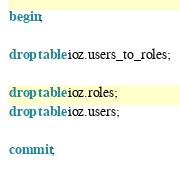<code> <loc_0><loc_0><loc_500><loc_500><_SQL_>begin;

drop table ioz.users_to_roles;

drop table ioz.roles;
drop table ioz.users;

commit;</code> 